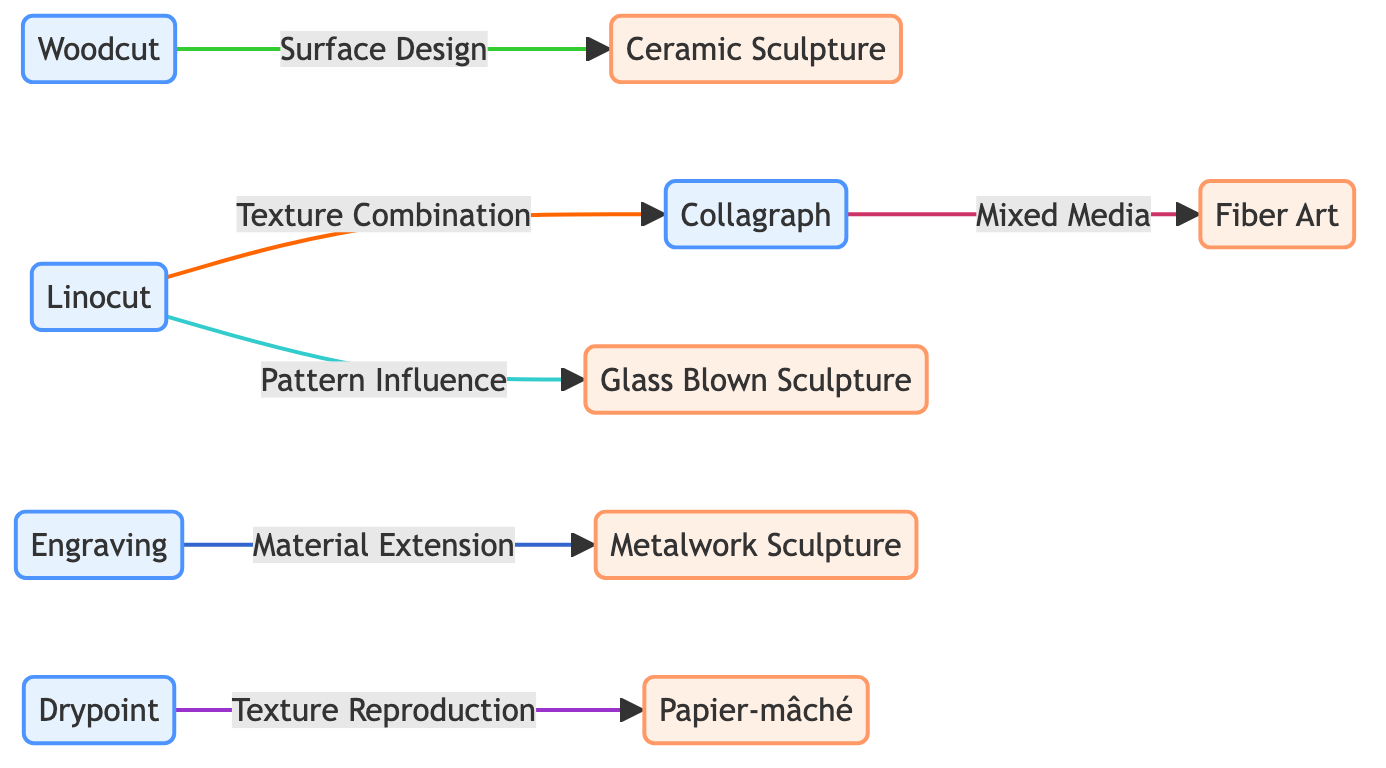What is the total number of textures represented in the diagram? There are six unique printmaking techniques listed as nodes: Linocut, Engraving, Collagraph, Woodcut, and Drypoint. Thus, the total number is six.
Answer: 6 Which printmaking technique connects to the Ceramic Sculpture node? The diagram shows that the Woodcut technique connects to Ceramic Sculpture through the relationship labeled as surface design.
Answer: Woodcut What type of relationship exists between Linocut and Collagraph? The diagram indicates that the relationship between Linocut and Collagraph is defined as texture combination.
Answer: texture combination How many three-dimensional art forms are depicted in the diagram? The diagram lists five three-dimensional art forms: Ceramic Sculpture, Metalwork Sculpture, Papier-mâché, Fiber Art, and Glass Blown Sculpture, totaling five.
Answer: 5 Which printmaking technique is related to Fiber Art? The diagram shows that Collagraph is connected to Fiber Art through the mixed media relationship.
Answer: Collagraph What is the primary influence of Linocut on Glass Blown Sculpture according to the diagram? The relationship labeled as pattern influence indicates that Linocut patterns influence the designs in Glass Blown Sculpture.
Answer: pattern influence Which two printmaking techniques link to the Drypoint technique, demonstrating different relationships? The Drypoint technique links to two different nodes: it connects to Papier-mâché through texture reproduction, and also is related to Collagraph through mixed media.
Answer: Papier-mâché and Collagraph What does the relationship between Engraving and Metalwork Sculpture represent? The diagram describes this relationship as material extension, indicating how engraving techniques are adapted into metalworking for sculptures.
Answer: material extension Identify the node that primarily focuses on textural elements in the context of the diagram. The Collagraph node primarily focuses on textural elements, engaging with other forms of art through its unique texture combination and mixed media attributes.
Answer: Collagraph 